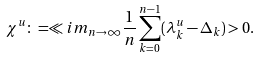<formula> <loc_0><loc_0><loc_500><loc_500>\chi ^ { u } \colon = \ll i m _ { n \to \infty } \frac { 1 } { n } \sum _ { k = 0 } ^ { n - 1 } ( \lambda _ { k } ^ { u } - \Delta _ { k } ) > 0 .</formula> 